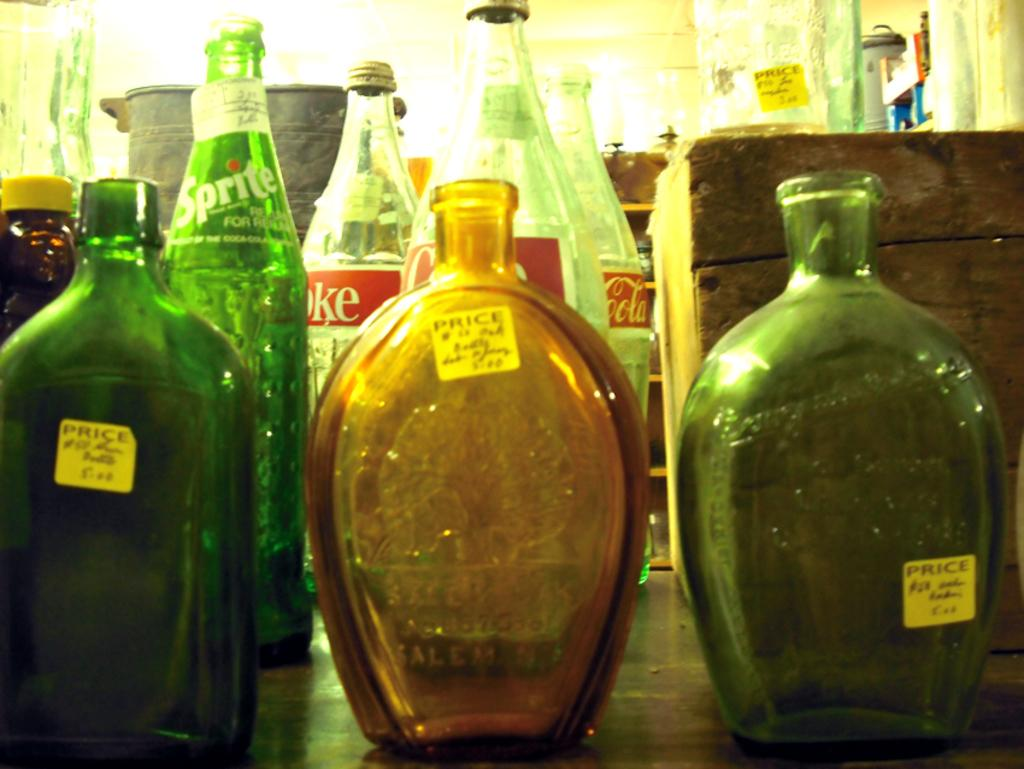<image>
Provide a brief description of the given image. Several bottles with stickers that say price on them. 